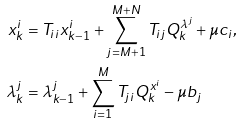<formula> <loc_0><loc_0><loc_500><loc_500>x ^ { i } _ { k } & = T _ { i i } x ^ { i } _ { k - 1 } + \sum _ { j = M + 1 } ^ { M + N } T _ { i j } Q ^ { \lambda ^ { j } } _ { k } + \mu c _ { i } , \\ \lambda ^ { j } _ { k } & = \lambda ^ { j } _ { k - 1 } + \sum _ { i = 1 } ^ { M } T _ { j i } Q ^ { x ^ { i } } _ { k } - \mu b _ { j }</formula> 